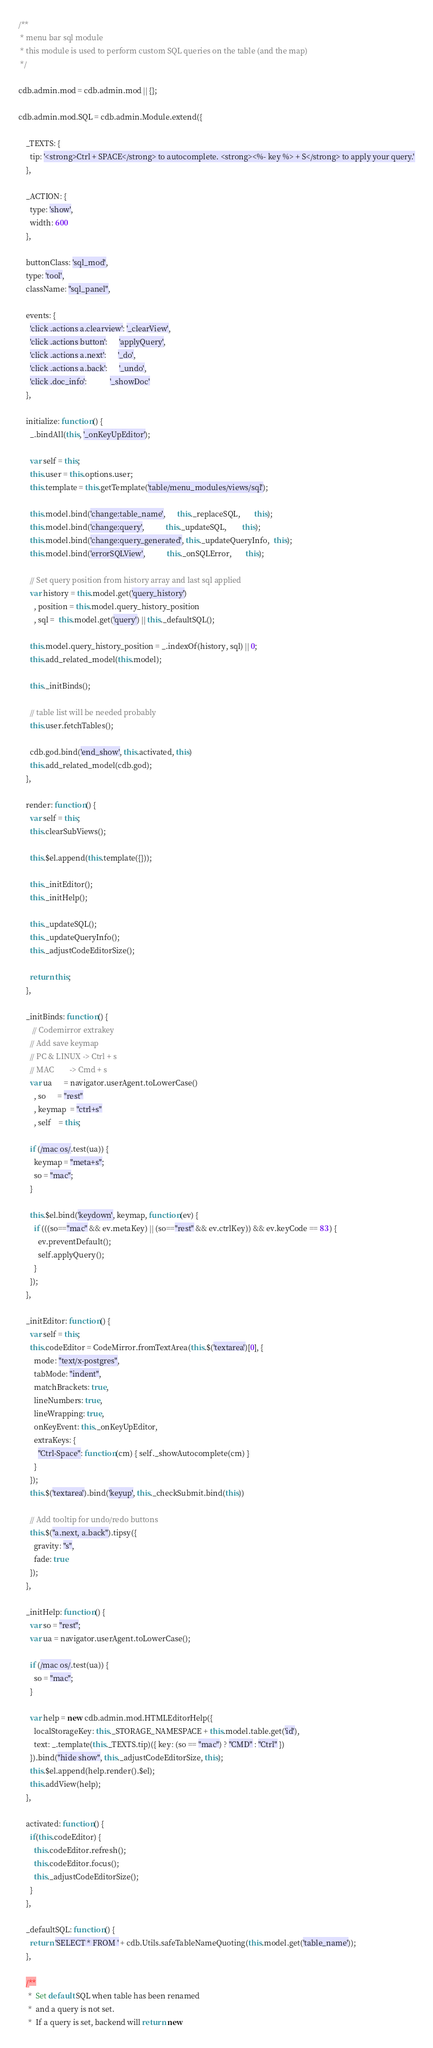<code> <loc_0><loc_0><loc_500><loc_500><_JavaScript_>/**
 * menu bar sql module
 * this module is used to perform custom SQL queries on the table (and the map)
 */

cdb.admin.mod = cdb.admin.mod || {};

cdb.admin.mod.SQL = cdb.admin.Module.extend({

    _TEXTS: {
      tip: '<strong>Ctrl + SPACE</strong> to autocomplete. <strong><%- key %> + S</strong> to apply your query.'
    },

    _ACTION: {
      type: 'show',
      width: 600
    },

    buttonClass: 'sql_mod',
    type: 'tool',
    className: "sql_panel",

    events: {
      'click .actions a.clearview': '_clearView',
      'click .actions button':      'applyQuery',
      'click .actions a.next':      '_do',
      'click .actions a.back':      '_undo',
      'click .doc_info':            '_showDoc'
    },

    initialize: function() {
      _.bindAll(this, '_onKeyUpEditor');

      var self = this;
      this.user = this.options.user;
      this.template = this.getTemplate('table/menu_modules/views/sql');

      this.model.bind('change:table_name',      this._replaceSQL,       this);
      this.model.bind('change:query',           this._updateSQL,        this);
      this.model.bind('change:query_generated', this._updateQueryInfo,  this);
      this.model.bind('errorSQLView',           this._onSQLError,       this);

      // Set query position from history array and last sql applied
      var history = this.model.get('query_history')
        , position = this.model.query_history_position
        , sql =  this.model.get('query') || this._defaultSQL();

      this.model.query_history_position = _.indexOf(history, sql) || 0;
      this.add_related_model(this.model);

      this._initBinds();

      // table list will be needed probably
      this.user.fetchTables();

      cdb.god.bind('end_show', this.activated, this)
      this.add_related_model(cdb.god);
    },

    render: function() {
      var self = this;
      this.clearSubViews();

      this.$el.append(this.template({}));

      this._initEditor();
      this._initHelp();

      this._updateSQL();
      this._updateQueryInfo();
      this._adjustCodeEditorSize();

      return this;
    },

    _initBinds: function() {
       // Codemirror extrakey
      // Add save keymap
      // PC & LINUX -> Ctrl + s
      // MAC        -> Cmd + s
      var ua      = navigator.userAgent.toLowerCase()
        , so      = "rest"
        , keymap  = "ctrl+s"
        , self    = this;

      if (/mac os/.test(ua)) {
        keymap = "meta+s";
        so = "mac";
      }

      this.$el.bind('keydown', keymap, function(ev) {
        if (((so=="mac" && ev.metaKey) || (so=="rest" && ev.ctrlKey)) && ev.keyCode == 83 ) {
          ev.preventDefault();
          self.applyQuery();
        }
      });
    },

    _initEditor: function() {
      var self = this;
      this.codeEditor = CodeMirror.fromTextArea(this.$('textarea')[0], {
        mode: "text/x-postgres",
        tabMode: "indent",
        matchBrackets: true,
        lineNumbers: true,
        lineWrapping: true,
        onKeyEvent: this._onKeyUpEditor,
        extraKeys: {
          "Ctrl-Space": function(cm) { self._showAutocomplete(cm) }
        }
      });
      this.$('textarea').bind('keyup', this._checkSubmit.bind(this))

      // Add tooltip for undo/redo buttons
      this.$("a.next, a.back").tipsy({
        gravity: "s",
        fade: true
      });
    },

    _initHelp: function() {
      var so = "rest";
      var ua = navigator.userAgent.toLowerCase();

      if (/mac os/.test(ua)) {
        so = "mac";
      }

      var help = new cdb.admin.mod.HTMLEditorHelp({
        localStorageKey: this._STORAGE_NAMESPACE + this.model.table.get('id'),
        text: _.template(this._TEXTS.tip)({ key: (so == "mac") ? "CMD" : "Ctrl" })
      }).bind("hide show", this._adjustCodeEditorSize, this);
      this.$el.append(help.render().$el);
      this.addView(help);
    },

    activated: function() {
      if(this.codeEditor) {
        this.codeEditor.refresh();
        this.codeEditor.focus();
        this._adjustCodeEditorSize();
      }
    },

    _defaultSQL: function() {
      return 'SELECT * FROM ' + cdb.Utils.safeTableNameQuoting(this.model.get('table_name'));
    },

    /**
     *  Set default SQL when table has been renamed
     *  and a query is not set.
     *  If a query is set, backend will return new</code> 